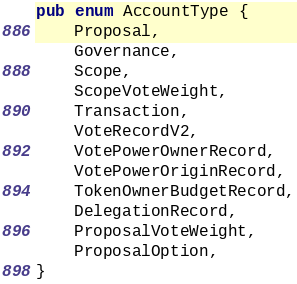<code> <loc_0><loc_0><loc_500><loc_500><_Rust_>pub enum AccountType {
    Proposal,
    Governance,
    Scope,
    ScopeVoteWeight,
    Transaction,
    VoteRecordV2,
    VotePowerOwnerRecord,
    VotePowerOriginRecord,
    TokenOwnerBudgetRecord,
    DelegationRecord,
    ProposalVoteWeight,
    ProposalOption,
}
</code> 